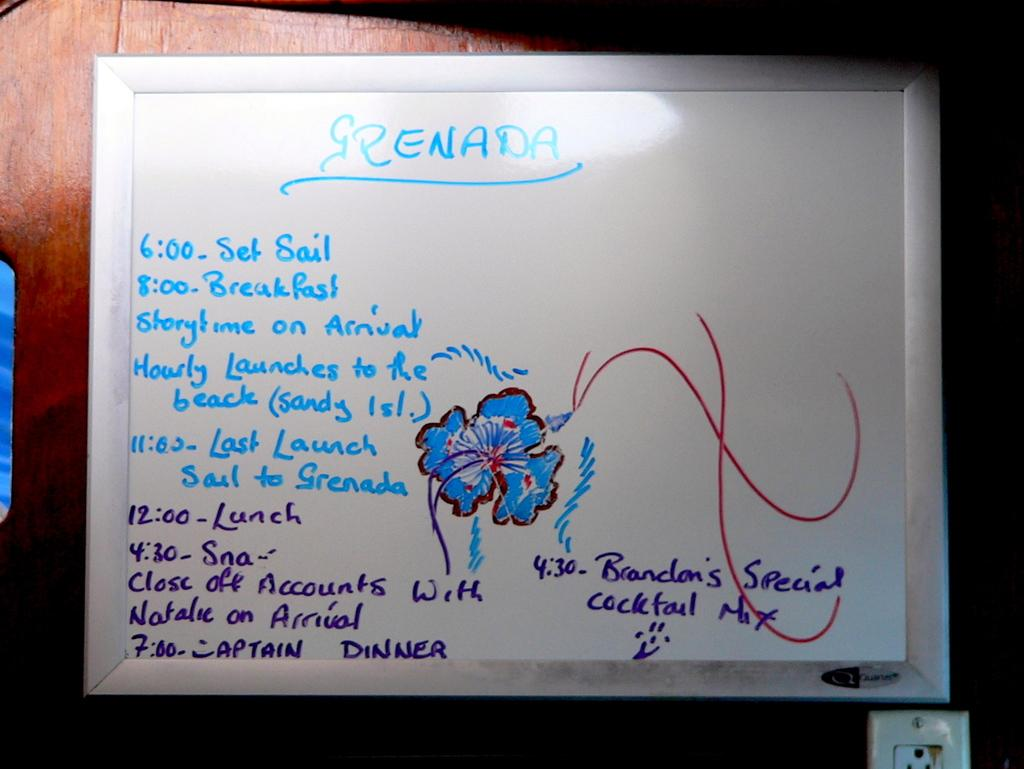What is on the wall in the image? There is a whiteboard on the wall in the image. What can be seen on the whiteboard? The whiteboard has text and a flower drawing on it. What is located under the whiteboard? There is a socket under the whiteboard. What type of dress is the person wearing at the event depicted on the whiteboard? There is no person or event depicted on the whiteboard; it only has text and a flower drawing. 